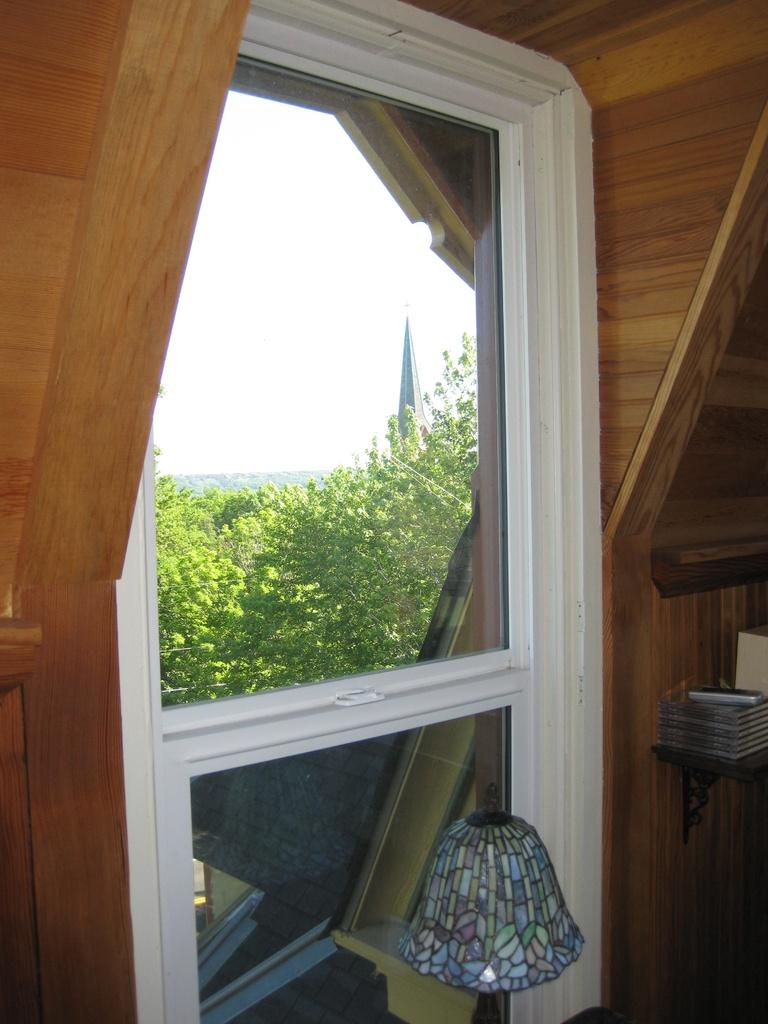What object can be seen in the image that provides light? There is a lamp in the image. What type of window is present in the image? There is a white color glass window in the image. What can be seen in the background of the image? There are green trees and the sky visible in the background of the image. What type of brass instrument is being played in the image? There is no brass instrument present in the image; it only features a lamp, a window, green trees, and the sky. 